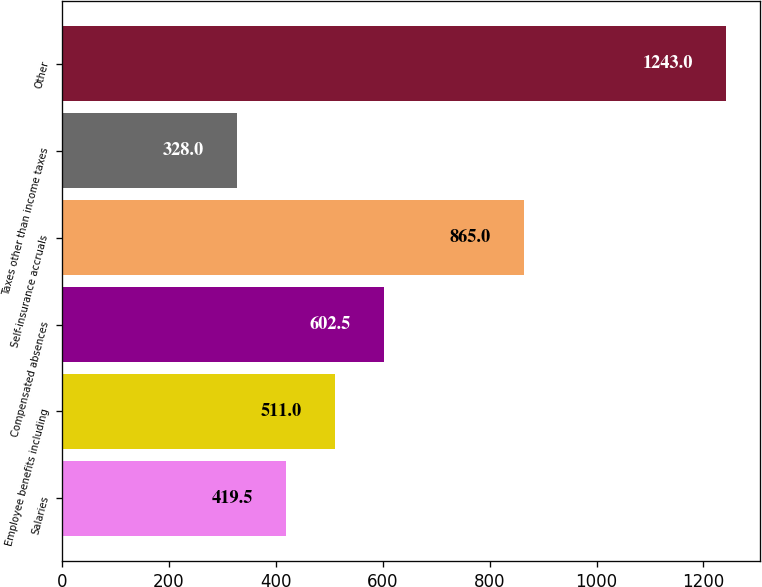<chart> <loc_0><loc_0><loc_500><loc_500><bar_chart><fcel>Salaries<fcel>Employee benefits including<fcel>Compensated absences<fcel>Self-insurance accruals<fcel>Taxes other than income taxes<fcel>Other<nl><fcel>419.5<fcel>511<fcel>602.5<fcel>865<fcel>328<fcel>1243<nl></chart> 